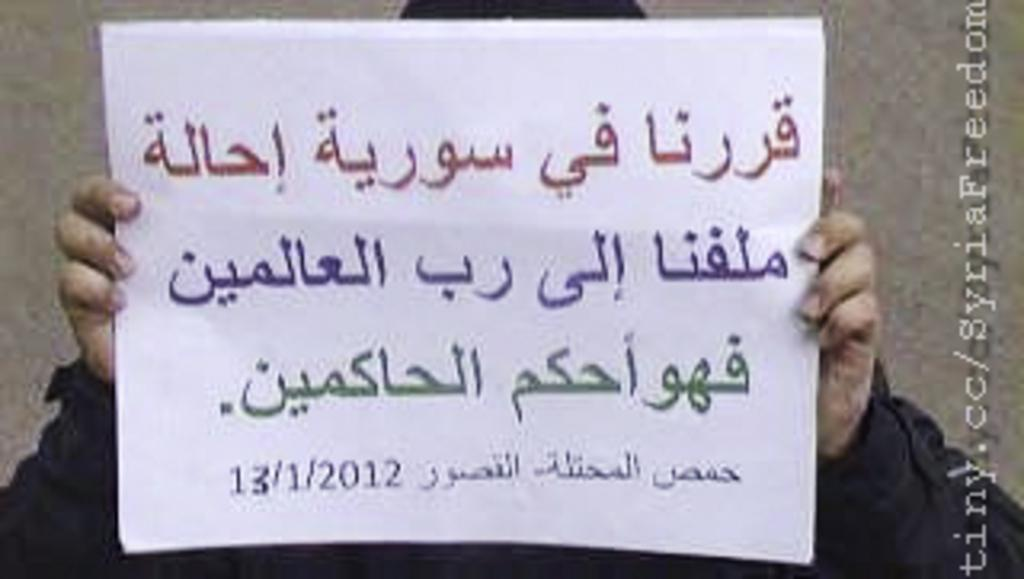Provide a one-sentence caption for the provided image. Someone holds a large piece of paper with arabic writing on it dated 13/1/2012 on it. 